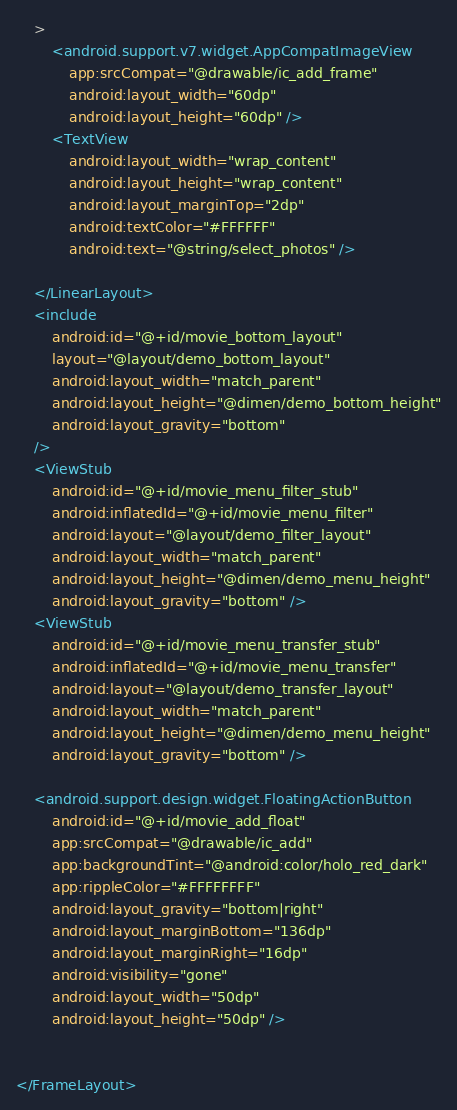<code> <loc_0><loc_0><loc_500><loc_500><_XML_>    >
        <android.support.v7.widget.AppCompatImageView
            app:srcCompat="@drawable/ic_add_frame"
            android:layout_width="60dp"
            android:layout_height="60dp" />
        <TextView
            android:layout_width="wrap_content"
            android:layout_height="wrap_content"
            android:layout_marginTop="2dp"
            android:textColor="#FFFFFF"
            android:text="@string/select_photos" />

    </LinearLayout>
    <include
        android:id="@+id/movie_bottom_layout"
        layout="@layout/demo_bottom_layout"
        android:layout_width="match_parent"
        android:layout_height="@dimen/demo_bottom_height"
        android:layout_gravity="bottom"
    />
    <ViewStub
        android:id="@+id/movie_menu_filter_stub"
        android:inflatedId="@+id/movie_menu_filter"
        android:layout="@layout/demo_filter_layout"
        android:layout_width="match_parent"
        android:layout_height="@dimen/demo_menu_height"
        android:layout_gravity="bottom" />
    <ViewStub
        android:id="@+id/movie_menu_transfer_stub"
        android:inflatedId="@+id/movie_menu_transfer"
        android:layout="@layout/demo_transfer_layout"
        android:layout_width="match_parent"
        android:layout_height="@dimen/demo_menu_height"
        android:layout_gravity="bottom" />

    <android.support.design.widget.FloatingActionButton
        android:id="@+id/movie_add_float"
        app:srcCompat="@drawable/ic_add"
        app:backgroundTint="@android:color/holo_red_dark"
        app:rippleColor="#FFFFFFFF"
        android:layout_gravity="bottom|right"
        android:layout_marginBottom="136dp"
        android:layout_marginRight="16dp"
        android:visibility="gone"
        android:layout_width="50dp"
        android:layout_height="50dp" />


</FrameLayout>
</code> 